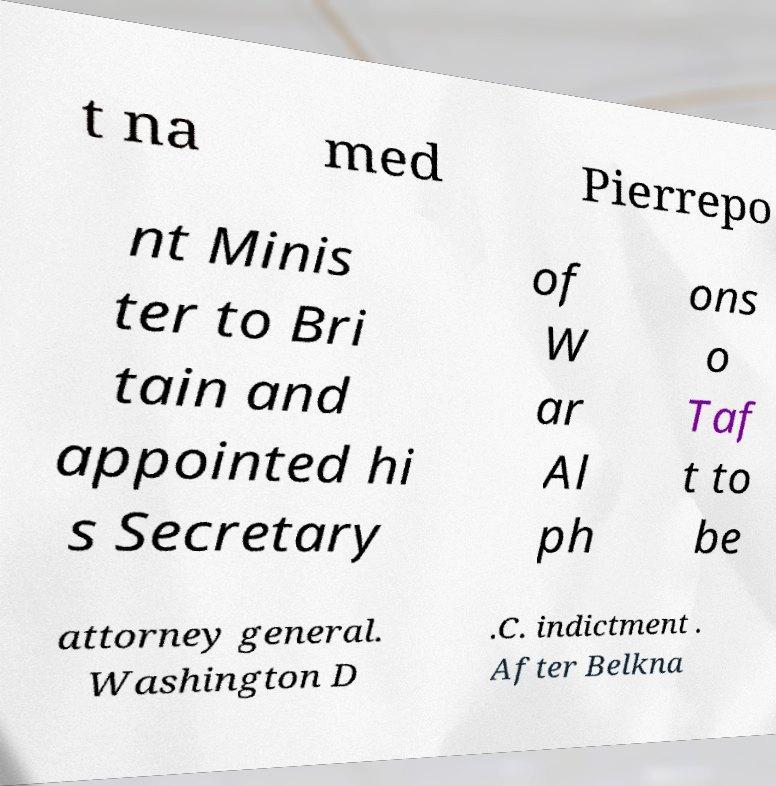Can you accurately transcribe the text from the provided image for me? t na med Pierrepo nt Minis ter to Bri tain and appointed hi s Secretary of W ar Al ph ons o Taf t to be attorney general. Washington D .C. indictment . After Belkna 